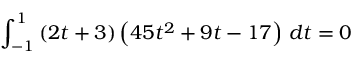Convert formula to latex. <formula><loc_0><loc_0><loc_500><loc_500>\int _ { - 1 } ^ { 1 } \left ( 2 t + 3 \right ) \left ( 4 5 t ^ { 2 } + 9 t - 1 7 \right ) \, d t = 0</formula> 